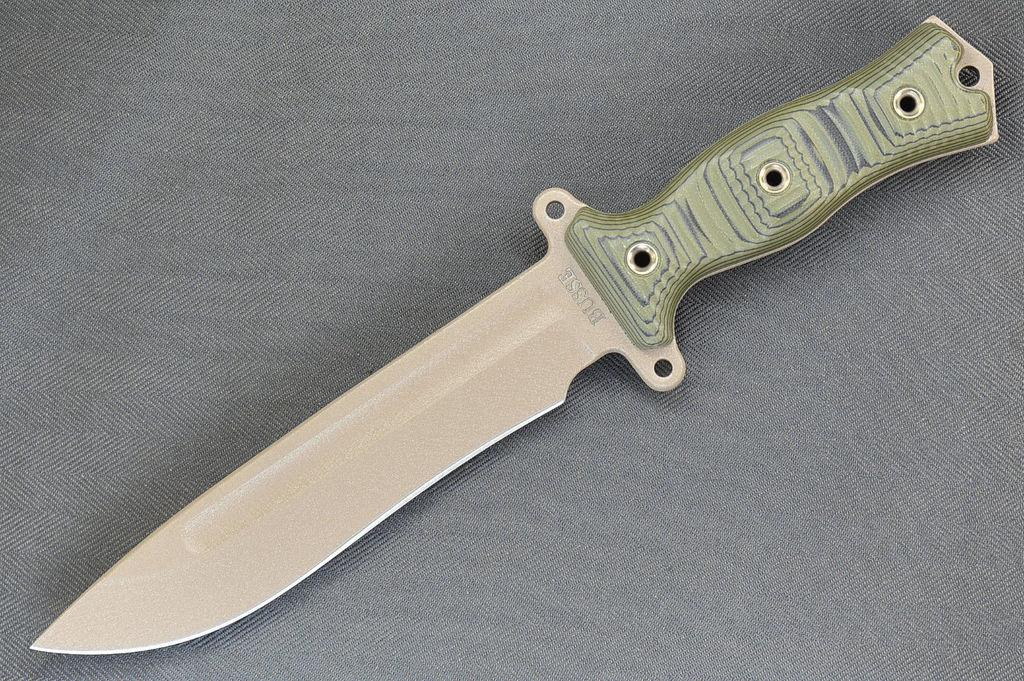What object can be seen in the image? There is a knife in the image. Where is the knife located? The knife is placed on a cloth. What sound does the kettle make in the image? There is no kettle present in the image, so it cannot make any sound. 